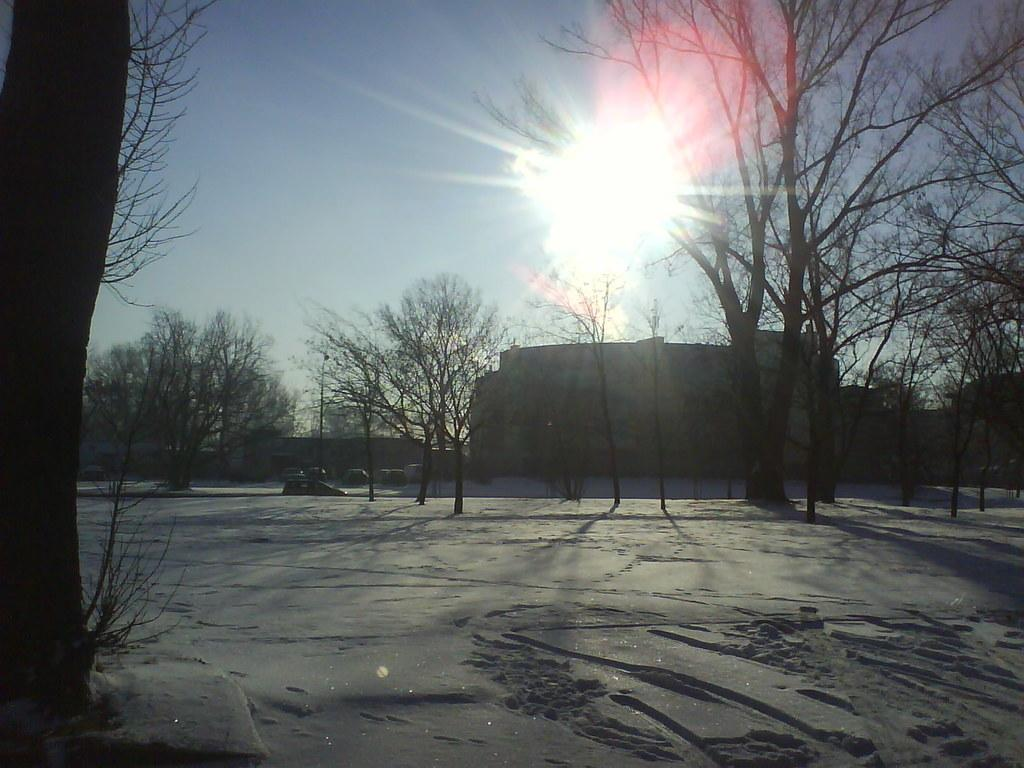What type of natural elements can be seen in the image? There are trees in the image. What is visible in the background of the image? There is a building and the sky visible in the background of the image. Can the sun be seen in the image? Yes, the sun is observable in the sky. What type of flowers can be seen growing near the building in the image? There are no flowers visible in the image; only trees, a building, and the sky are present. 